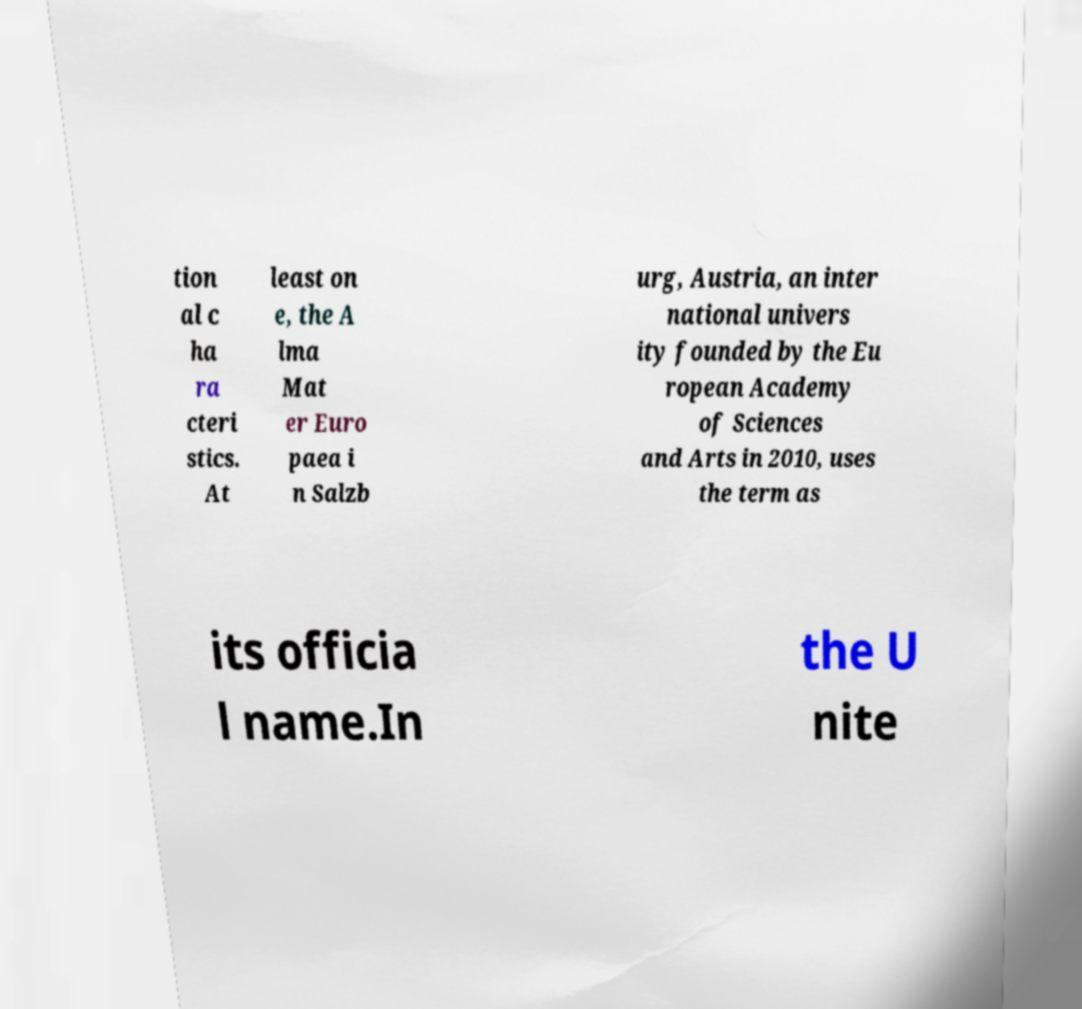For documentation purposes, I need the text within this image transcribed. Could you provide that? tion al c ha ra cteri stics. At least on e, the A lma Mat er Euro paea i n Salzb urg, Austria, an inter national univers ity founded by the Eu ropean Academy of Sciences and Arts in 2010, uses the term as its officia l name.In the U nite 